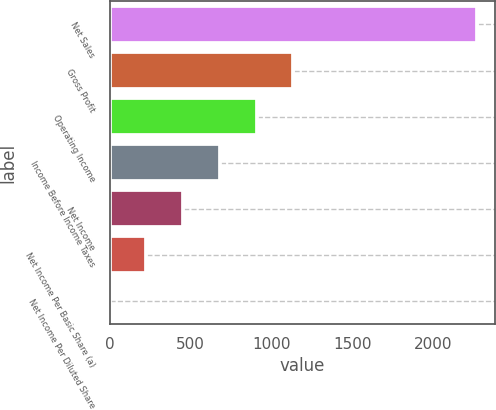<chart> <loc_0><loc_0><loc_500><loc_500><bar_chart><fcel>Net Sales<fcel>Gross Profit<fcel>Operating Income<fcel>Income Before Income Taxes<fcel>Net Income<fcel>Net Income Per Basic Share (a)<fcel>Net Income Per Diluted Share<nl><fcel>2268<fcel>1134.23<fcel>907.48<fcel>680.73<fcel>453.98<fcel>227.23<fcel>0.48<nl></chart> 